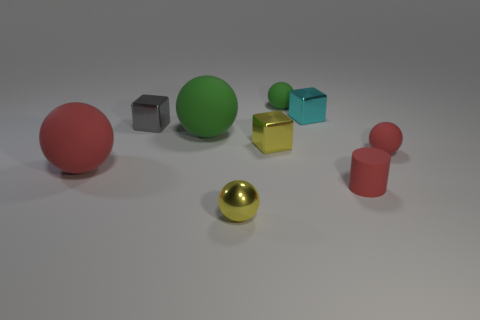Subtract all yellow spheres. How many spheres are left? 4 Subtract all brown balls. Subtract all brown cubes. How many balls are left? 5 Add 1 tiny red rubber spheres. How many objects exist? 10 Subtract all spheres. How many objects are left? 4 Subtract 0 brown cubes. How many objects are left? 9 Subtract all large matte things. Subtract all big green balls. How many objects are left? 6 Add 5 tiny red balls. How many tiny red balls are left? 6 Add 8 tiny purple matte blocks. How many tiny purple matte blocks exist? 8 